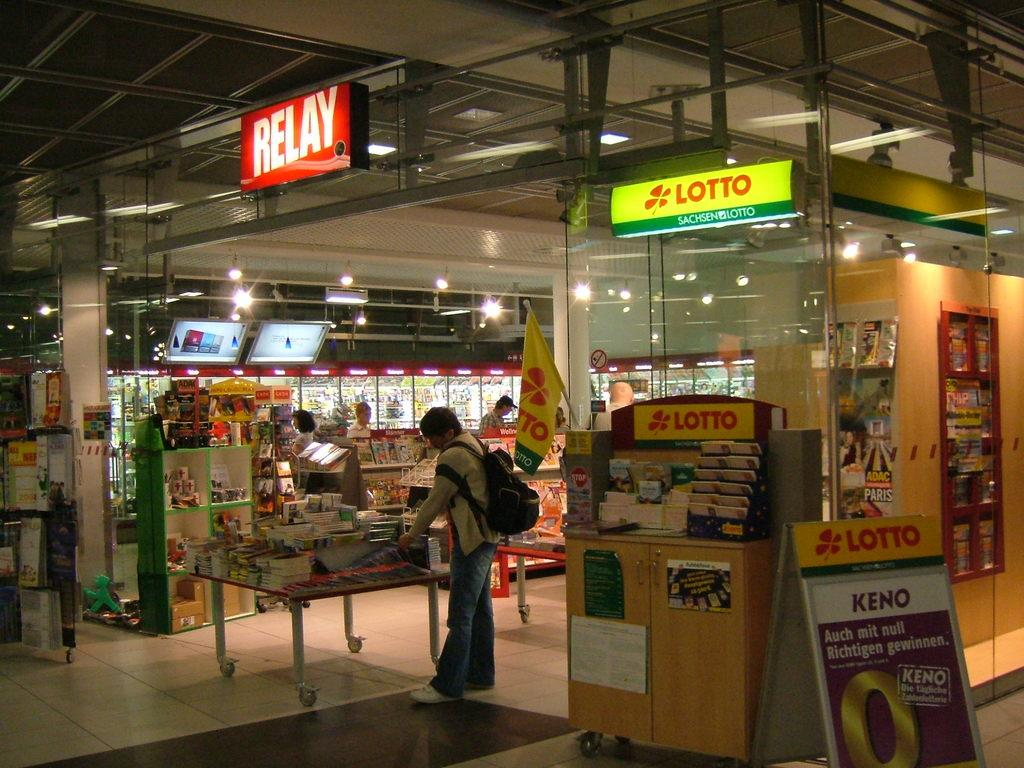<image>
Relay a brief, clear account of the picture shown. a shopping place has a lotto kiosk lit up 